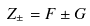Convert formula to latex. <formula><loc_0><loc_0><loc_500><loc_500>Z _ { \pm } = F \pm G</formula> 